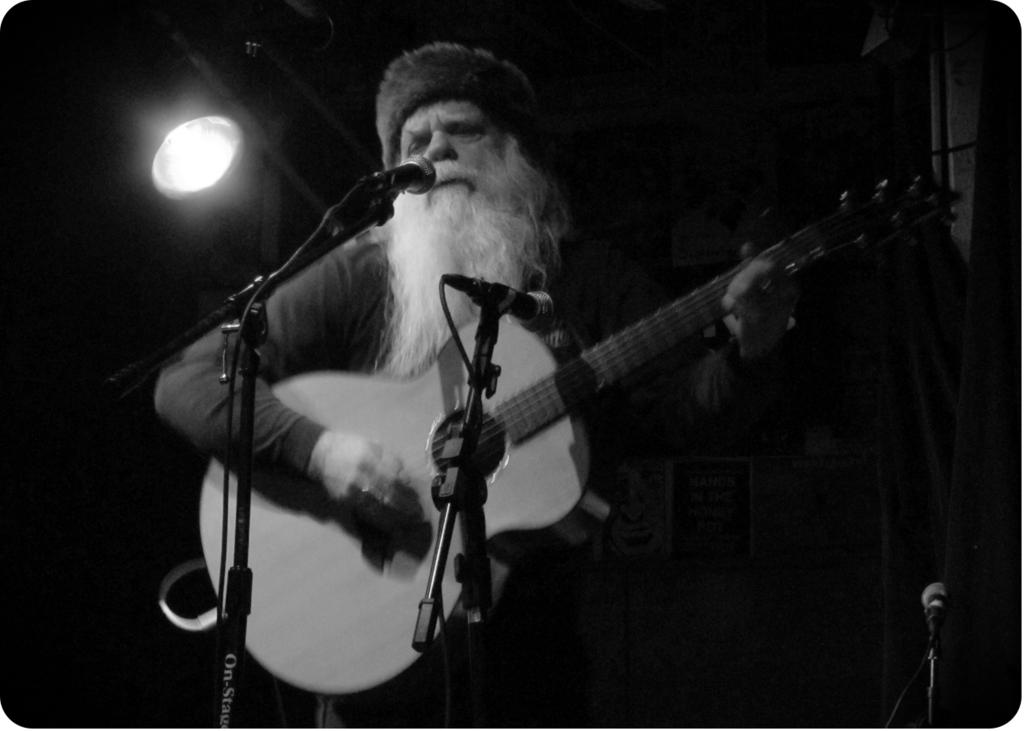What is the man in the image doing? The man is playing the guitar. What is the man wearing on his head? The man is wearing a cap. What instrument is the man holding? The man is holding a guitar. What equipment is set up in front of the man? There are microphones and mic stands in front of the man. What can be seen in the background of the image? There is a light in the background of the image. Does the man in the image express any hatred towards his aunt? There is no mention of an aunt or any emotions in the image, so it cannot be determined if the man expresses any hatred. 